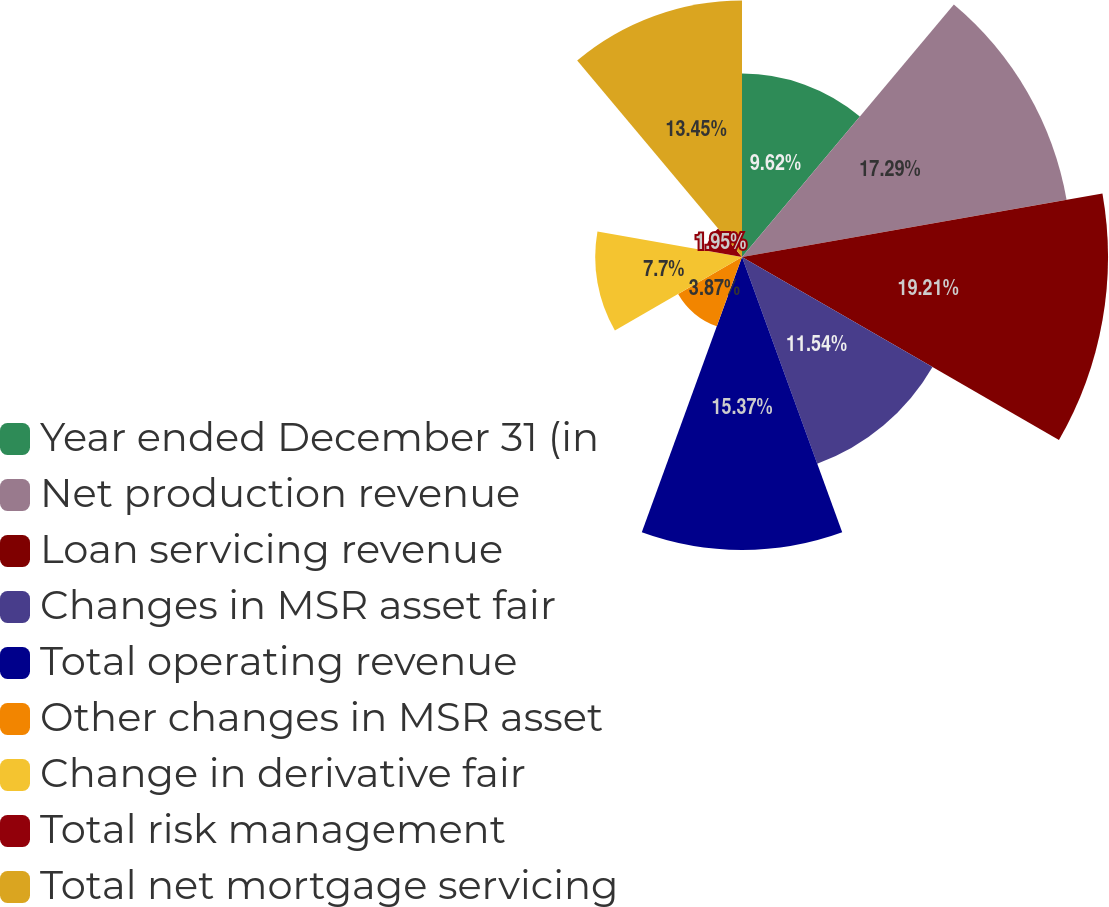Convert chart to OTSL. <chart><loc_0><loc_0><loc_500><loc_500><pie_chart><fcel>Year ended December 31 (in<fcel>Net production revenue<fcel>Loan servicing revenue<fcel>Changes in MSR asset fair<fcel>Total operating revenue<fcel>Other changes in MSR asset<fcel>Change in derivative fair<fcel>Total risk management<fcel>Total net mortgage servicing<nl><fcel>9.62%<fcel>17.29%<fcel>19.2%<fcel>11.54%<fcel>15.37%<fcel>3.87%<fcel>7.7%<fcel>1.95%<fcel>13.45%<nl></chart> 